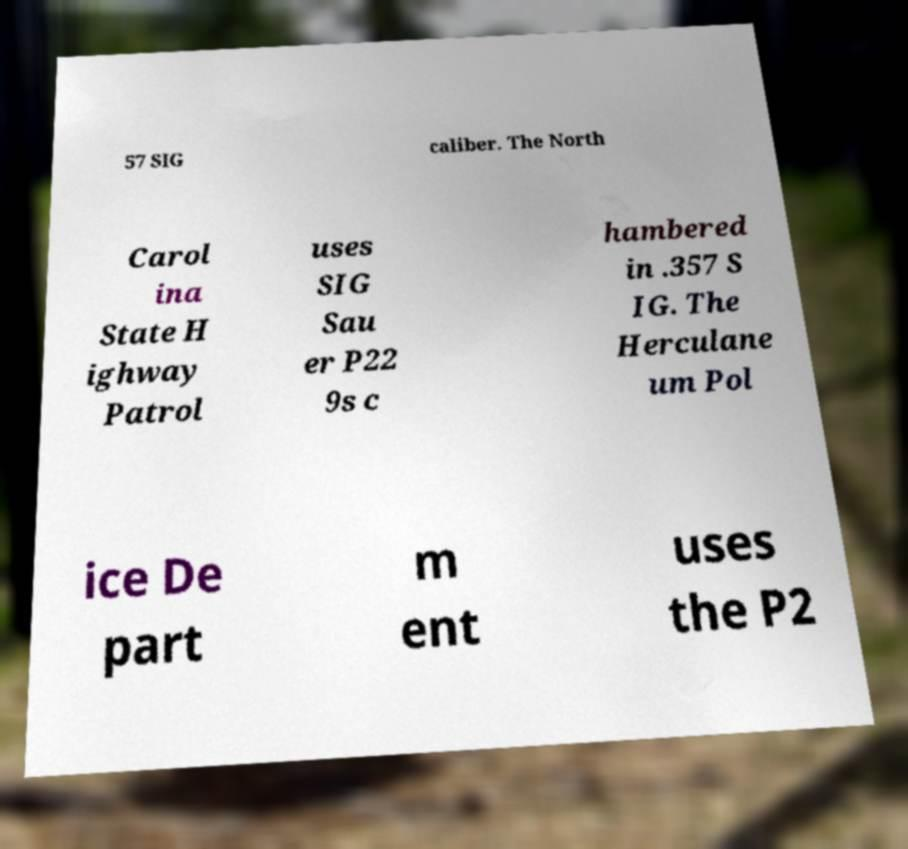For documentation purposes, I need the text within this image transcribed. Could you provide that? 57 SIG caliber. The North Carol ina State H ighway Patrol uses SIG Sau er P22 9s c hambered in .357 S IG. The Herculane um Pol ice De part m ent uses the P2 